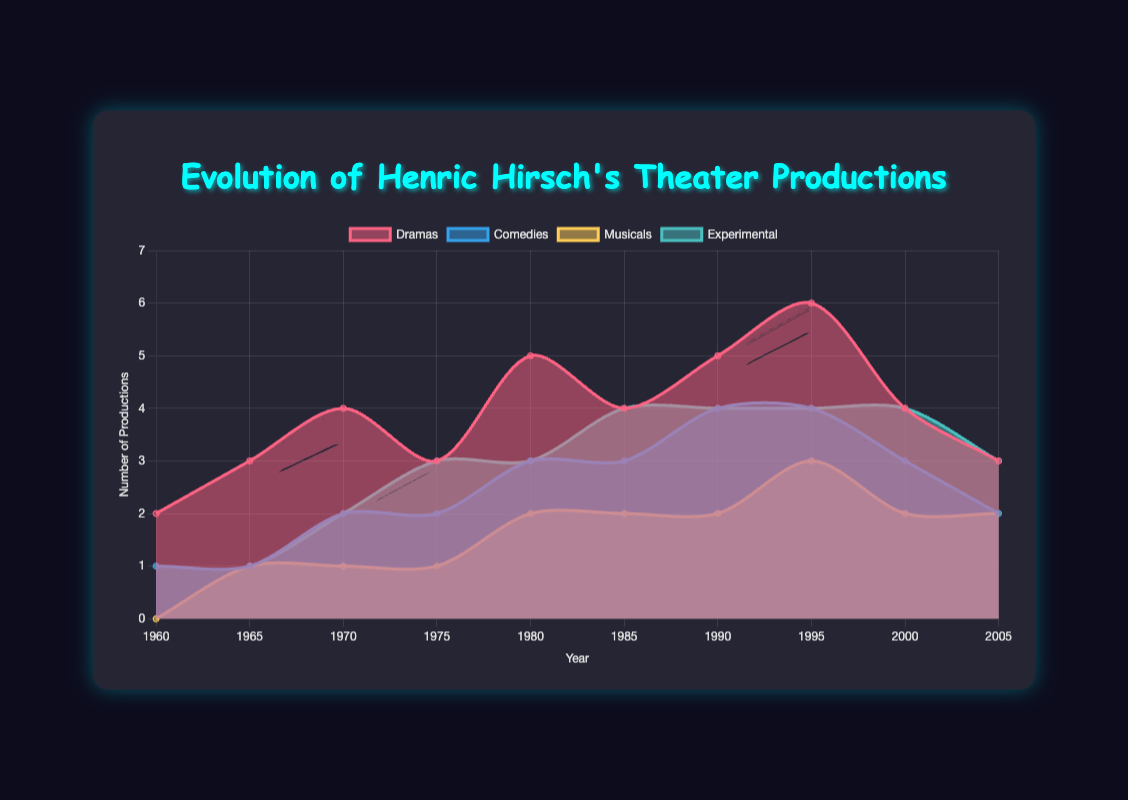What is the title of the chart? The title is shown at the top center of the chart. It reads "Evolution of Henric Hirsch's Theater Productions."
Answer: Evolution of Henric Hirsch's Theater Productions How many different types of plays are represented in the chart? The chart has four distinct datasets, each representing a type of play: Dramas, Comedies, Musicals, and Experimental.
Answer: Four Which type of play had the highest number of productions in 1980? Looking at the value for each play type in 1980: Dramas (5), Comedies (3), Musicals (2), Experimental (3). Dramas have the highest value.
Answer: Dramas In which year did Experimental plays first reach 4 productions? By observing the Experimental dataset, the first instance reaching 4 productions is in 1985.
Answer: 1985 What is the most common number of productions for Musicals across all years? Analyze the Musicals dataset, the most frequent values are 1 and 2, each appearing multiple times.
Answer: 1 and 2 How many productions were there in total in 1970 across all play types? Summing the values in 1970: Dramas (4) + Comedies (2) + Musicals (1) + Experimental (2) = 9.
Answer: 9 Which type of play showed the most consistent increase over time? Comparing the trends in the datasets, most types have fluctuations, but Experimental shows a more consistent increase before stabilizing.
Answer: Experimental Which year saw the peak of total theater productions across all play types? Summing the productions year by year and finding the maximum: 1960 (4), 1965 (6), 1970 (9), 1975 (9), 1980 (13), 1985 (13), 1990 (15), 1995 (17), 2000 (13), 2005 (10). The peak is in 1995.
Answer: 1995 In what year did Dramas surpass the number of Comedies for the first time? Observing the datasets, Dramas surpass Comedies when they go from 2 to 3 (surpassing at 1965)
Answer: 1965 